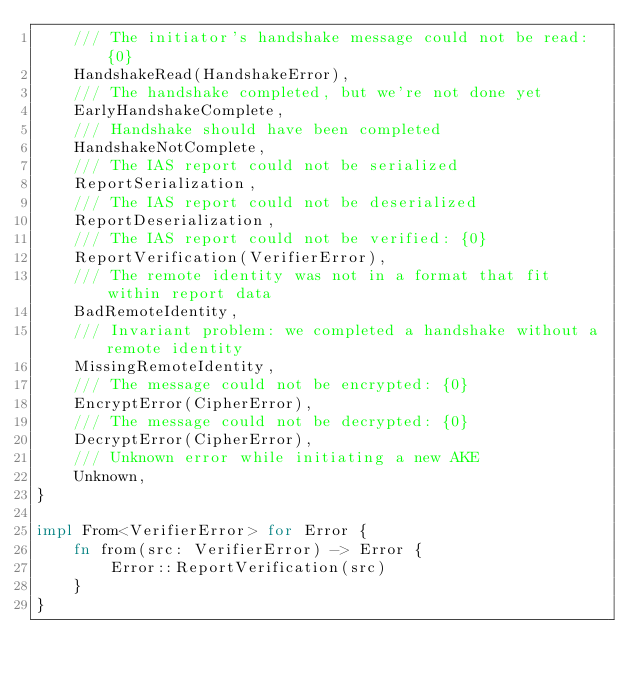<code> <loc_0><loc_0><loc_500><loc_500><_Rust_>    /// The initiator's handshake message could not be read: {0}
    HandshakeRead(HandshakeError),
    /// The handshake completed, but we're not done yet
    EarlyHandshakeComplete,
    /// Handshake should have been completed
    HandshakeNotComplete,
    /// The IAS report could not be serialized
    ReportSerialization,
    /// The IAS report could not be deserialized
    ReportDeserialization,
    /// The IAS report could not be verified: {0}
    ReportVerification(VerifierError),
    /// The remote identity was not in a format that fit within report data
    BadRemoteIdentity,
    /// Invariant problem: we completed a handshake without a remote identity
    MissingRemoteIdentity,
    /// The message could not be encrypted: {0}
    EncryptError(CipherError),
    /// The message could not be decrypted: {0}
    DecryptError(CipherError),
    /// Unknown error while initiating a new AKE
    Unknown,
}

impl From<VerifierError> for Error {
    fn from(src: VerifierError) -> Error {
        Error::ReportVerification(src)
    }
}
</code> 